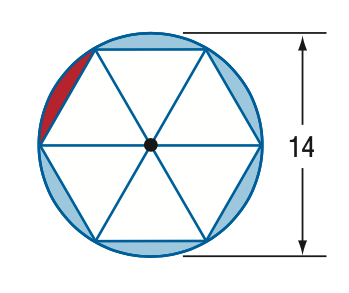Answer the mathemtical geometry problem and directly provide the correct option letter.
Question: A regular hexagon is inscribed in a circle with a diameter of 14. Find the area of the red segment.
Choices: A: 4.44 B: 8.88 C: 21.22 D: 25.66 A 